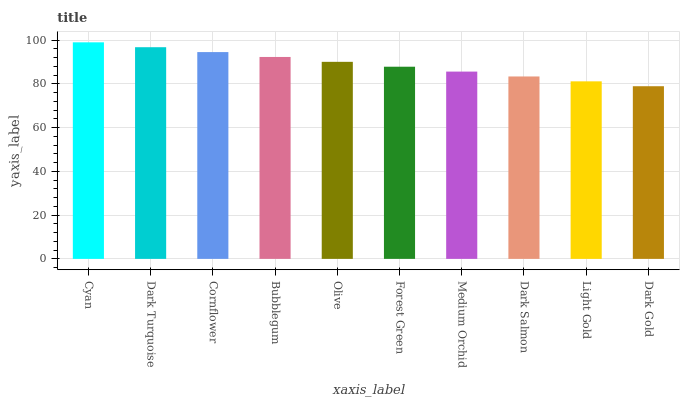Is Dark Turquoise the minimum?
Answer yes or no. No. Is Dark Turquoise the maximum?
Answer yes or no. No. Is Cyan greater than Dark Turquoise?
Answer yes or no. Yes. Is Dark Turquoise less than Cyan?
Answer yes or no. Yes. Is Dark Turquoise greater than Cyan?
Answer yes or no. No. Is Cyan less than Dark Turquoise?
Answer yes or no. No. Is Olive the high median?
Answer yes or no. Yes. Is Forest Green the low median?
Answer yes or no. Yes. Is Cyan the high median?
Answer yes or no. No. Is Olive the low median?
Answer yes or no. No. 